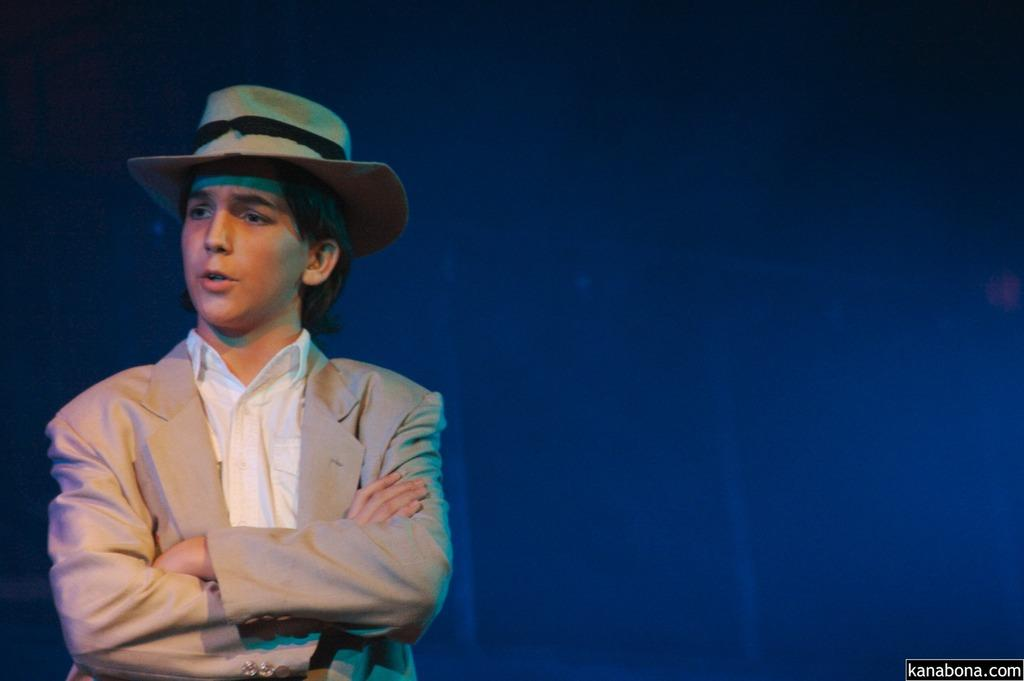What can be seen on the left side of the image? There is a person standing on the left side of the image. What is the person wearing on their head? The person is wearing a cap. What color is the background of the image? The background of the image is blue. What type of ray is swimming in the image? There is no ray present in the image; it features a person standing on the left side and wearing a cap, with a blue background. 